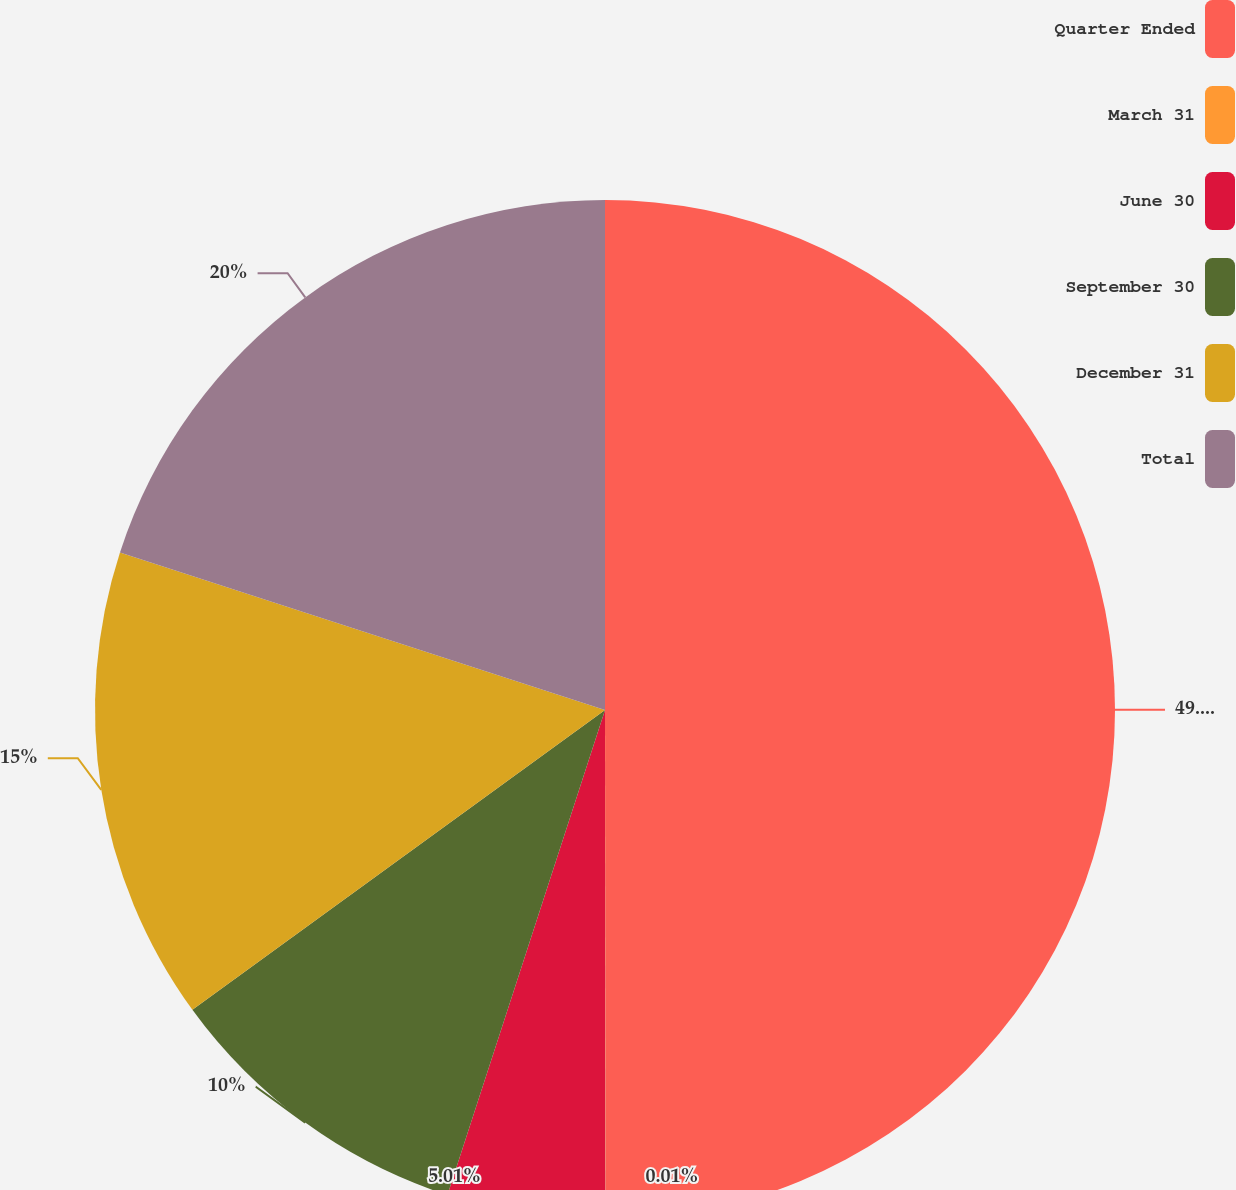Convert chart. <chart><loc_0><loc_0><loc_500><loc_500><pie_chart><fcel>Quarter Ended<fcel>March 31<fcel>June 30<fcel>September 30<fcel>December 31<fcel>Total<nl><fcel>49.98%<fcel>0.01%<fcel>5.01%<fcel>10.0%<fcel>15.0%<fcel>20.0%<nl></chart> 